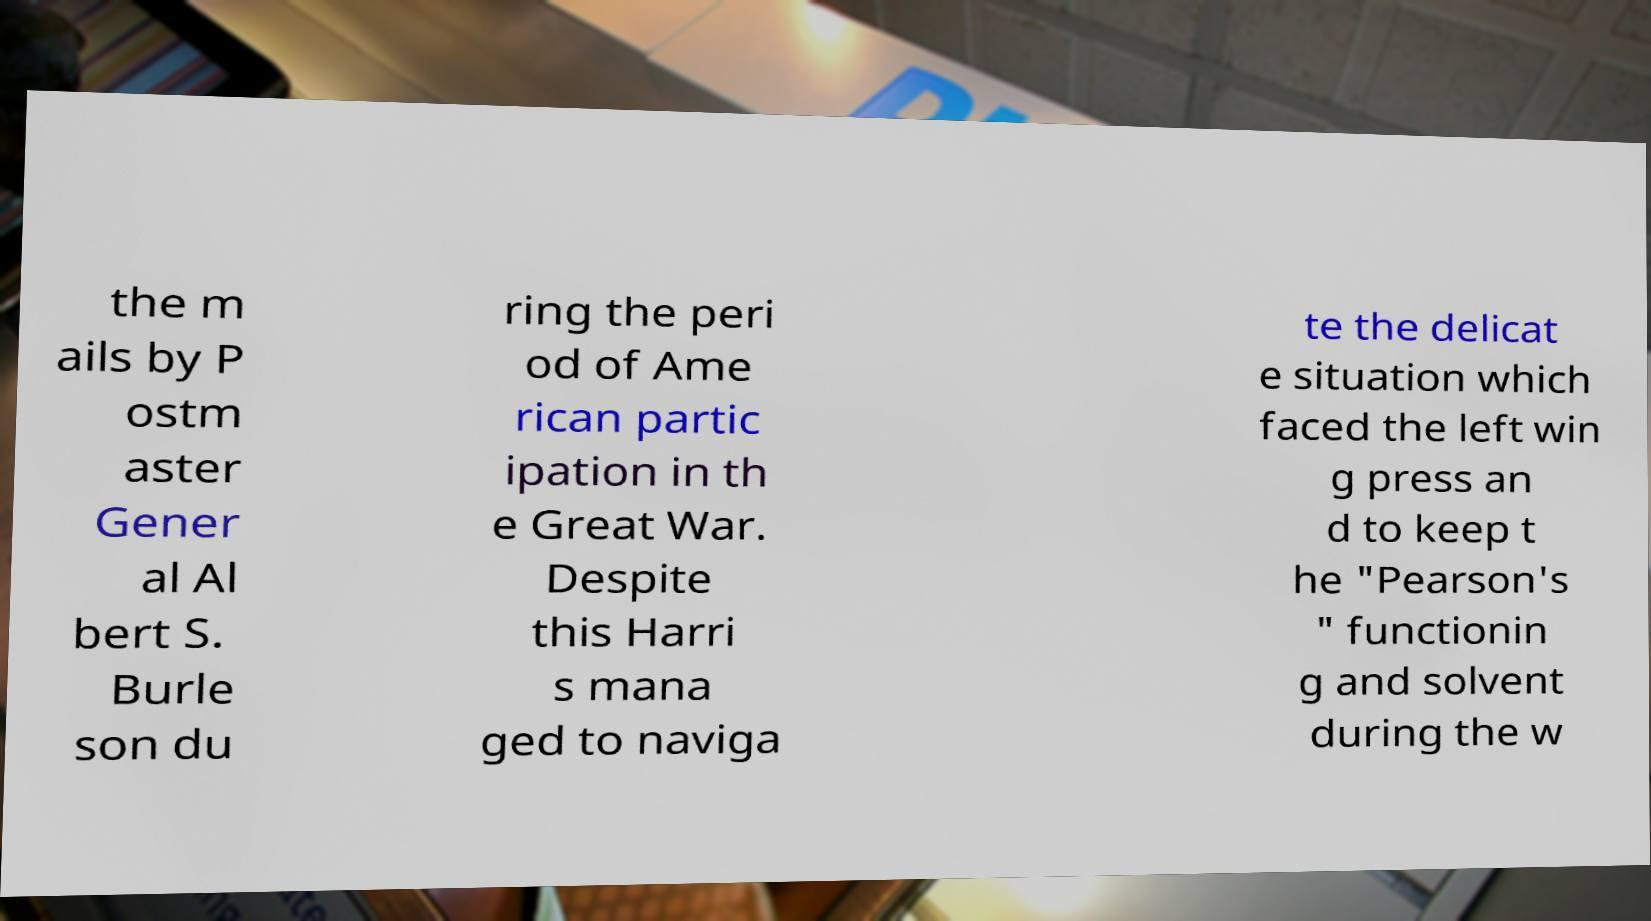Please identify and transcribe the text found in this image. the m ails by P ostm aster Gener al Al bert S. Burle son du ring the peri od of Ame rican partic ipation in th e Great War. Despite this Harri s mana ged to naviga te the delicat e situation which faced the left win g press an d to keep t he "Pearson's " functionin g and solvent during the w 